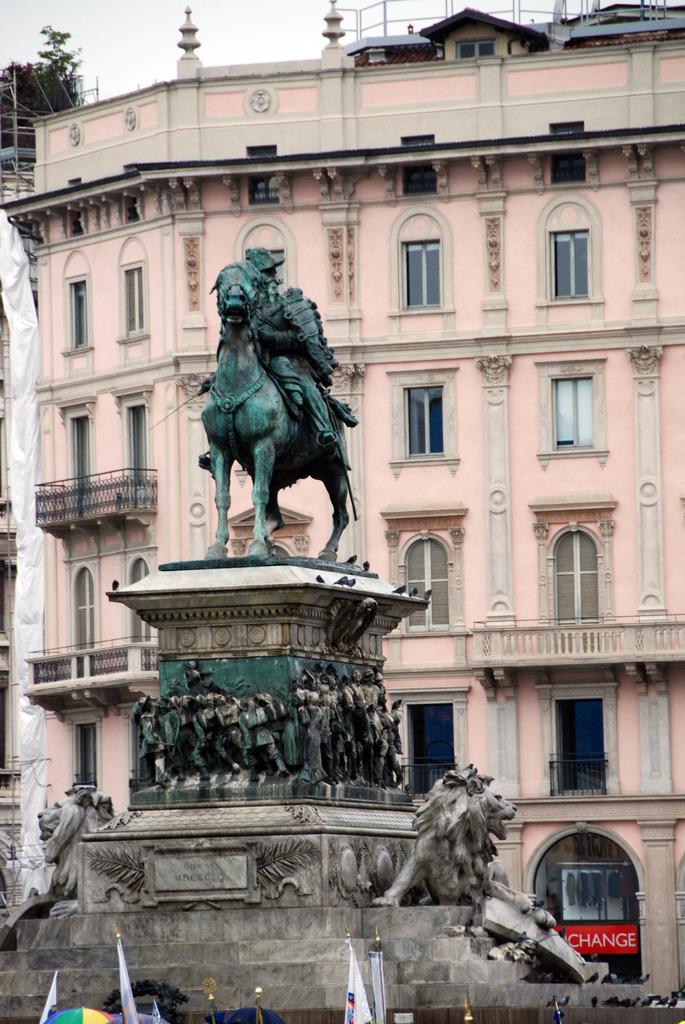What does it say on the red sign?
Your response must be concise. Change. 